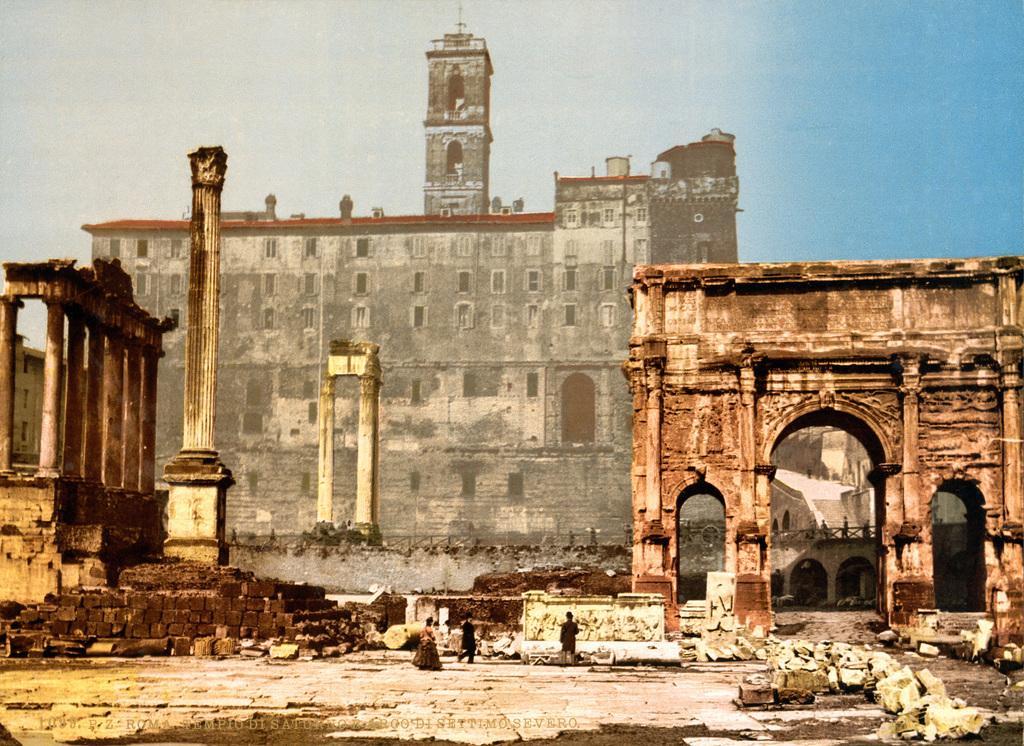Can you describe this image briefly? In this image I can see few buildings and the buildings are in gray and brown color, I can also see few persons walking. Background the sky is in blue and white color. 